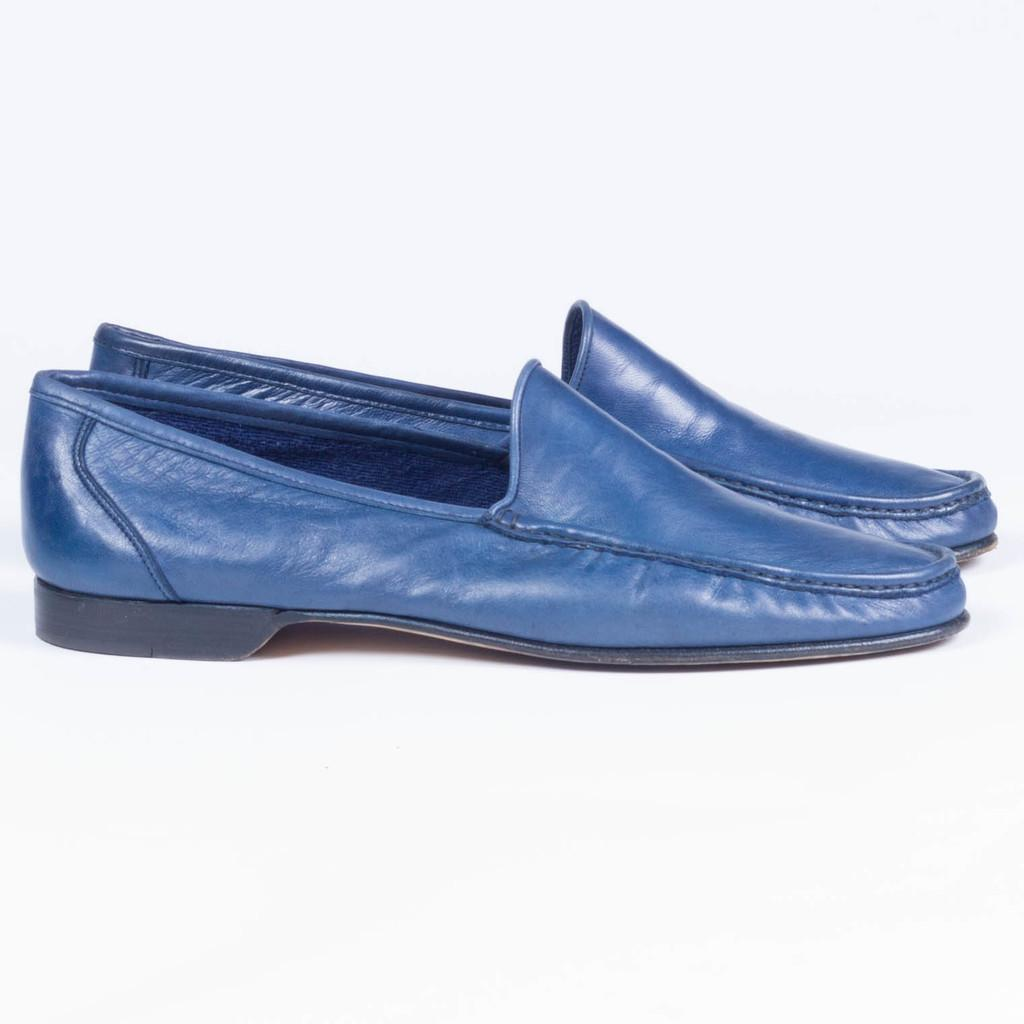What color are the shoes in the image? The shoes in the image are blue in color. What color is the background of the image? The background of the image is white in color. What is the name of the person wearing the blue shoes in the image? There is no person visible in the image, only the shoes. Therefore, we cannot determine the name of the person wearing the shoes. 